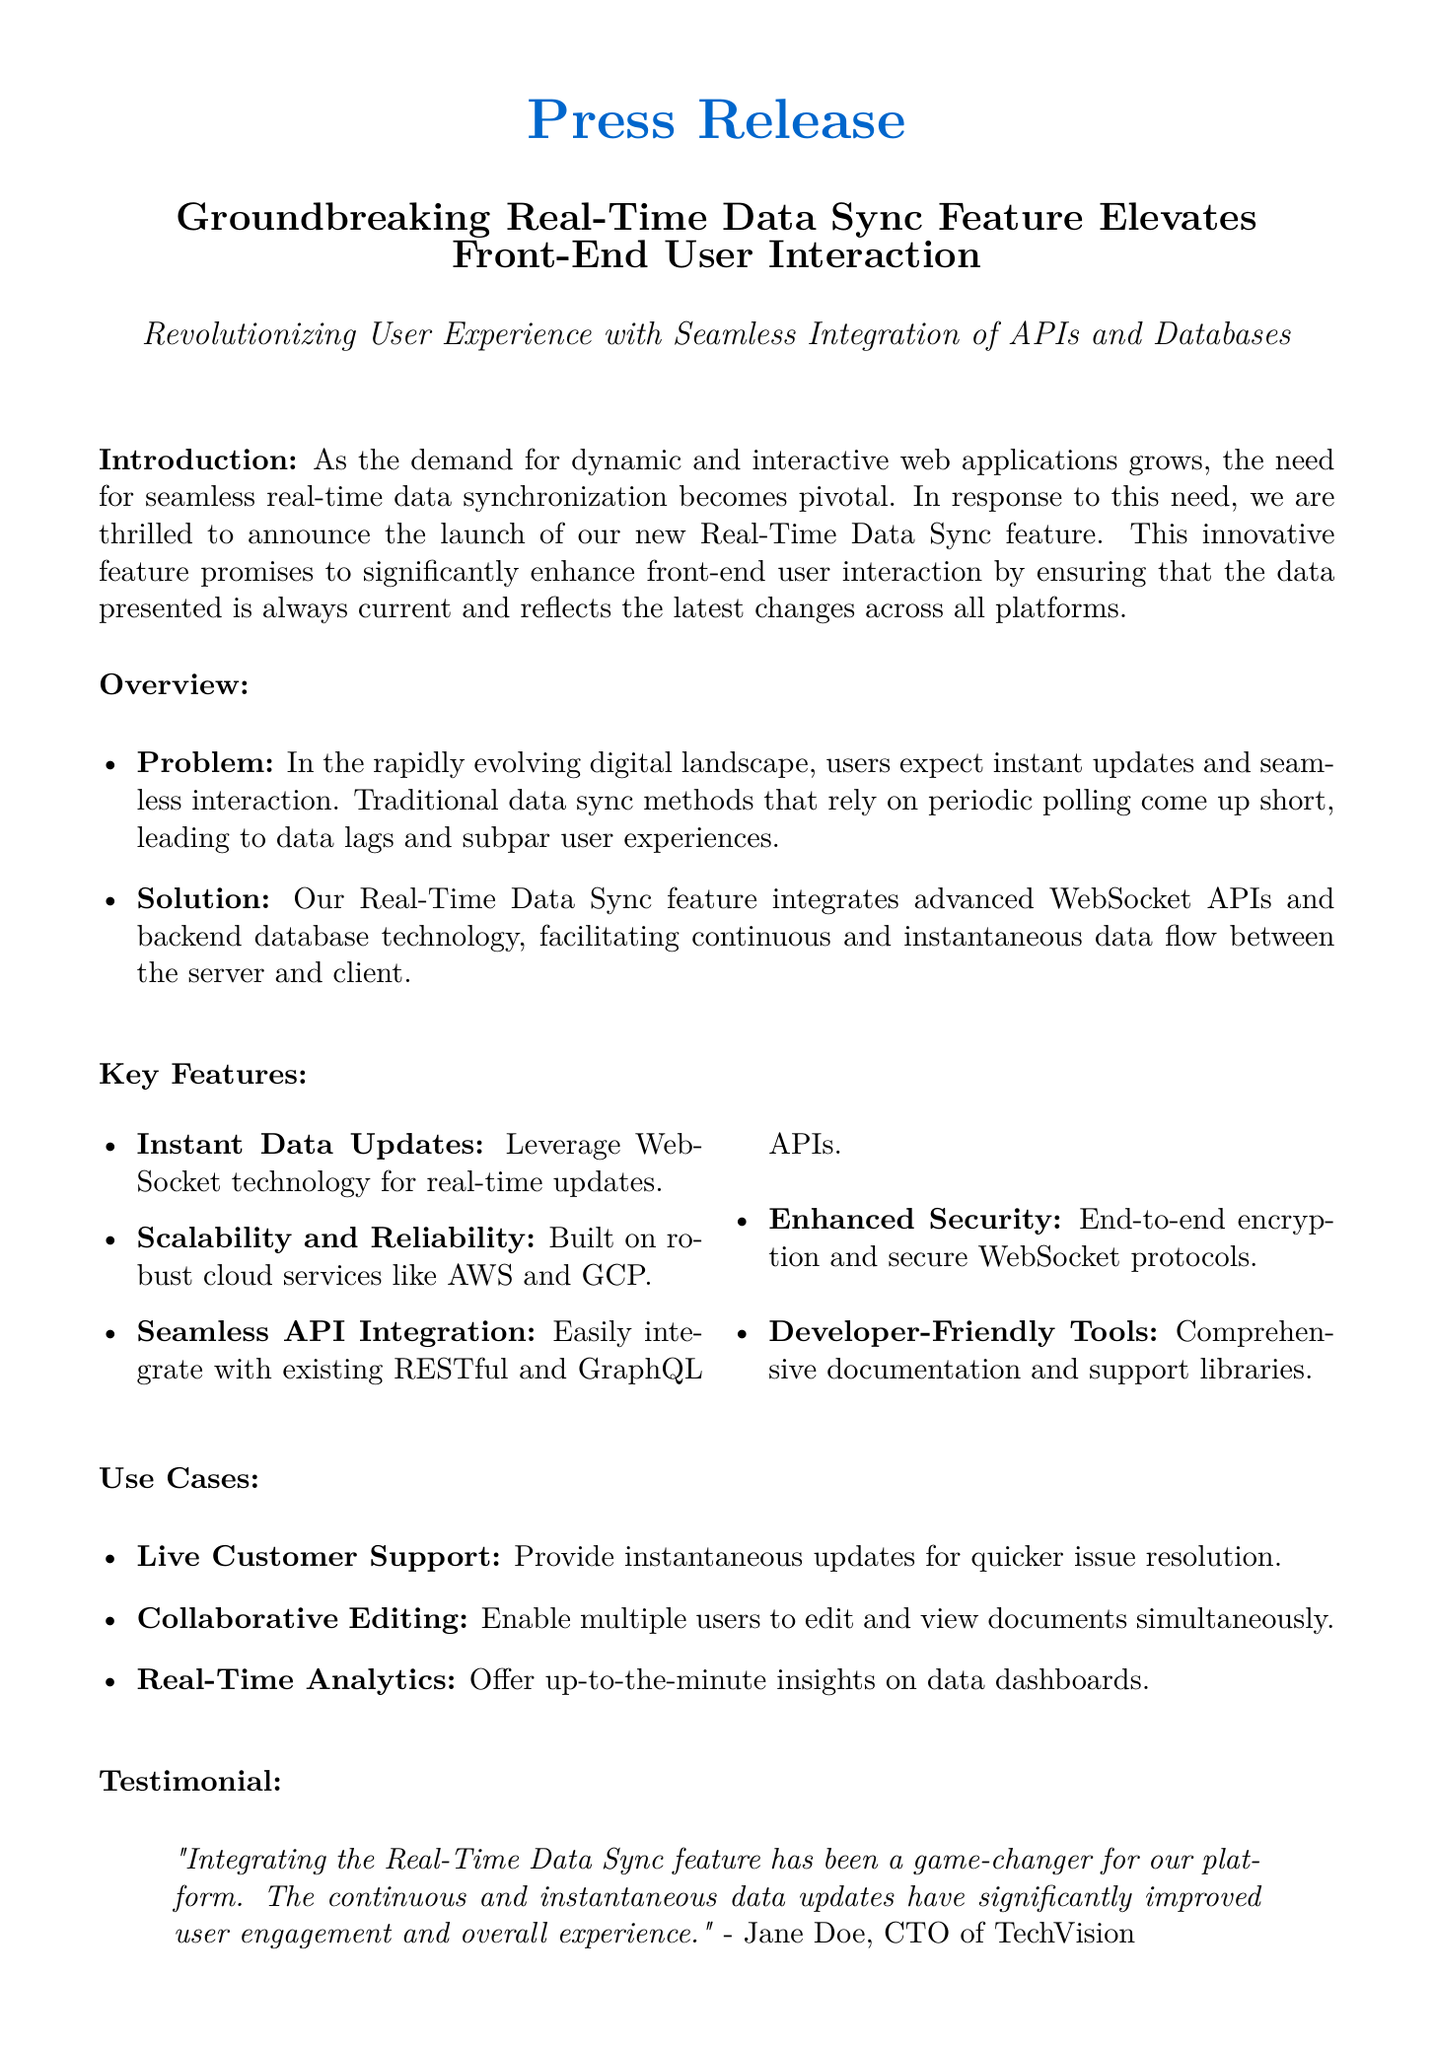What is the name of the new feature? The name of the new feature is mentioned in the title of the press release.
Answer: Real-Time Data Sync Who is the CTO of TechVision? The testimonial within the document provides the name of the CTO associated with the quote.
Answer: Jane Doe Which cloud services are mentioned for scalability? The overview section lists specific cloud services that provide scalability and reliability.
Answer: AWS and GCP What is a use case for the Real-Time Data Sync feature? The document outlines several use cases; one example is stated explicitly in the use cases section.
Answer: Live Customer Support What technology is used for instant data updates? The key features section specifically mentions the technology used for data updates.
Answer: WebSocket technology What is highlighted as a benefit of integrating the new feature? The testimonial section describes improvements associated with the integration of the feature.
Answer: User engagement What is one aspect of the feature's security? The key features section outlines a security characteristic of the new feature.
Answer: End-to-end encryption What type of APIs can the new feature easily integrate with? The key features section lists the types of APIs relevant for integration with the Real-Time Data Sync feature.
Answer: RESTful and GraphQL APIs 